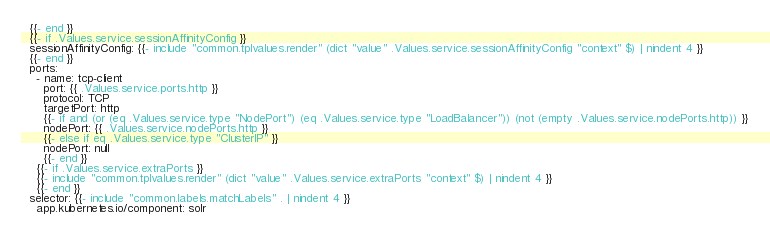Convert code to text. <code><loc_0><loc_0><loc_500><loc_500><_YAML_>  {{- end }}
  {{- if .Values.service.sessionAffinityConfig }}
  sessionAffinityConfig: {{- include "common.tplvalues.render" (dict "value" .Values.service.sessionAffinityConfig "context" $) | nindent 4 }}
  {{- end }}
  ports:
    - name: tcp-client
      port: {{ .Values.service.ports.http }}
      protocol: TCP
      targetPort: http
      {{- if and (or (eq .Values.service.type "NodePort") (eq .Values.service.type "LoadBalancer")) (not (empty .Values.service.nodePorts.http)) }}
      nodePort: {{ .Values.service.nodePorts.http }}
      {{- else if eq .Values.service.type "ClusterIP" }}
      nodePort: null
      {{- end }}
    {{- if .Values.service.extraPorts }}
    {{- include "common.tplvalues.render" (dict "value" .Values.service.extraPorts "context" $) | nindent 4 }}
    {{- end }}
  selector: {{- include "common.labels.matchLabels" . | nindent 4 }}
    app.kubernetes.io/component: solr
</code> 